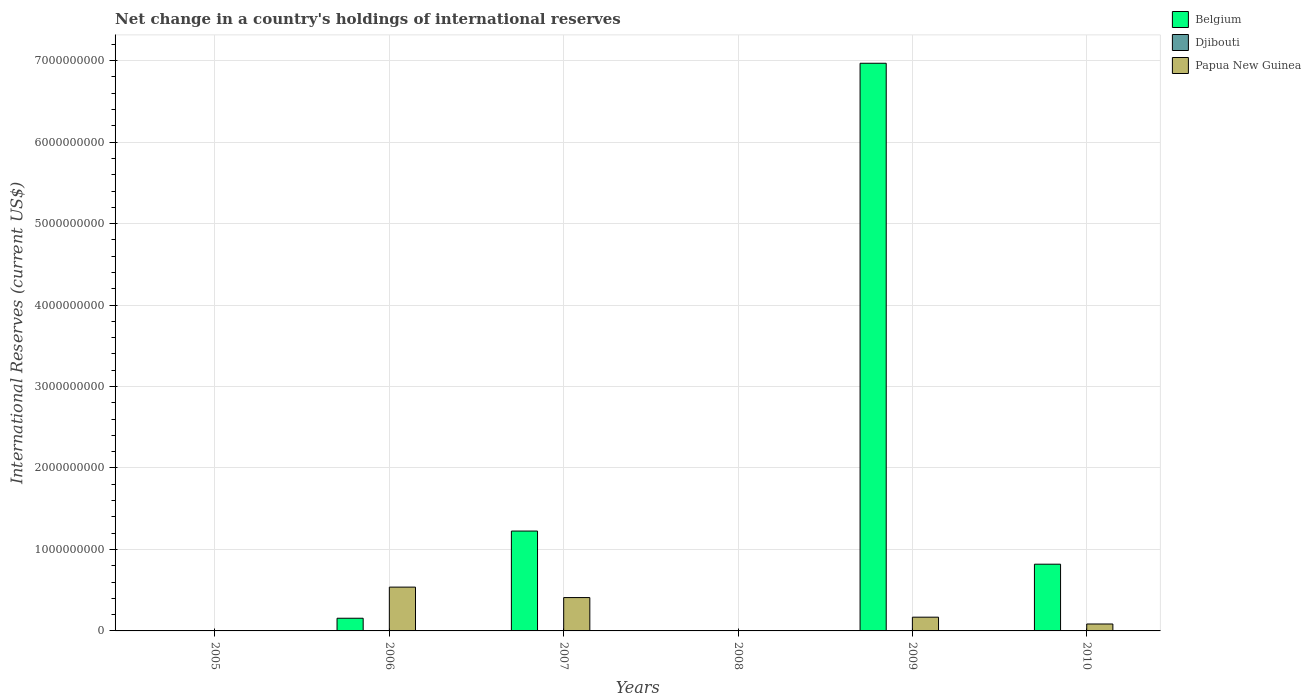Are the number of bars on each tick of the X-axis equal?
Offer a very short reply. No. How many bars are there on the 6th tick from the right?
Offer a very short reply. 0. What is the label of the 3rd group of bars from the left?
Make the answer very short. 2007. What is the international reserves in Papua New Guinea in 2010?
Keep it short and to the point. 8.50e+07. Across all years, what is the maximum international reserves in Papua New Guinea?
Ensure brevity in your answer.  5.38e+08. Across all years, what is the minimum international reserves in Papua New Guinea?
Provide a short and direct response. 0. In which year was the international reserves in Belgium maximum?
Provide a succinct answer. 2009. What is the total international reserves in Papua New Guinea in the graph?
Keep it short and to the point. 1.20e+09. What is the difference between the international reserves in Papua New Guinea in 2007 and that in 2010?
Offer a very short reply. 3.24e+08. What is the difference between the international reserves in Djibouti in 2007 and the international reserves in Papua New Guinea in 2006?
Offer a very short reply. -5.38e+08. What is the average international reserves in Belgium per year?
Give a very brief answer. 1.53e+09. In the year 2006, what is the difference between the international reserves in Papua New Guinea and international reserves in Belgium?
Provide a succinct answer. 3.82e+08. What is the ratio of the international reserves in Belgium in 2006 to that in 2010?
Your answer should be very brief. 0.19. Is the international reserves in Belgium in 2007 less than that in 2010?
Offer a very short reply. No. Is the difference between the international reserves in Papua New Guinea in 2006 and 2010 greater than the difference between the international reserves in Belgium in 2006 and 2010?
Provide a short and direct response. Yes. What is the difference between the highest and the second highest international reserves in Belgium?
Your answer should be very brief. 5.74e+09. What is the difference between the highest and the lowest international reserves in Djibouti?
Your response must be concise. 4.65e+06. How many bars are there?
Ensure brevity in your answer.  9. What is the difference between two consecutive major ticks on the Y-axis?
Keep it short and to the point. 1.00e+09. Does the graph contain grids?
Ensure brevity in your answer.  Yes. Where does the legend appear in the graph?
Provide a succinct answer. Top right. How many legend labels are there?
Your answer should be very brief. 3. How are the legend labels stacked?
Ensure brevity in your answer.  Vertical. What is the title of the graph?
Provide a succinct answer. Net change in a country's holdings of international reserves. What is the label or title of the Y-axis?
Keep it short and to the point. International Reserves (current US$). What is the International Reserves (current US$) in Djibouti in 2005?
Offer a very short reply. 0. What is the International Reserves (current US$) in Papua New Guinea in 2005?
Give a very brief answer. 0. What is the International Reserves (current US$) in Belgium in 2006?
Provide a short and direct response. 1.56e+08. What is the International Reserves (current US$) of Djibouti in 2006?
Give a very brief answer. 4.65e+06. What is the International Reserves (current US$) of Papua New Guinea in 2006?
Ensure brevity in your answer.  5.38e+08. What is the International Reserves (current US$) of Belgium in 2007?
Your response must be concise. 1.23e+09. What is the International Reserves (current US$) of Papua New Guinea in 2007?
Offer a very short reply. 4.09e+08. What is the International Reserves (current US$) of Djibouti in 2008?
Your answer should be very brief. 0. What is the International Reserves (current US$) in Belgium in 2009?
Give a very brief answer. 6.97e+09. What is the International Reserves (current US$) in Djibouti in 2009?
Ensure brevity in your answer.  0. What is the International Reserves (current US$) in Papua New Guinea in 2009?
Provide a short and direct response. 1.69e+08. What is the International Reserves (current US$) in Belgium in 2010?
Ensure brevity in your answer.  8.19e+08. What is the International Reserves (current US$) in Djibouti in 2010?
Keep it short and to the point. 0. What is the International Reserves (current US$) of Papua New Guinea in 2010?
Ensure brevity in your answer.  8.50e+07. Across all years, what is the maximum International Reserves (current US$) in Belgium?
Your response must be concise. 6.97e+09. Across all years, what is the maximum International Reserves (current US$) of Djibouti?
Give a very brief answer. 4.65e+06. Across all years, what is the maximum International Reserves (current US$) of Papua New Guinea?
Ensure brevity in your answer.  5.38e+08. Across all years, what is the minimum International Reserves (current US$) of Djibouti?
Ensure brevity in your answer.  0. What is the total International Reserves (current US$) of Belgium in the graph?
Your answer should be very brief. 9.17e+09. What is the total International Reserves (current US$) of Djibouti in the graph?
Keep it short and to the point. 4.65e+06. What is the total International Reserves (current US$) of Papua New Guinea in the graph?
Provide a succinct answer. 1.20e+09. What is the difference between the International Reserves (current US$) in Belgium in 2006 and that in 2007?
Your answer should be compact. -1.07e+09. What is the difference between the International Reserves (current US$) in Papua New Guinea in 2006 and that in 2007?
Provide a succinct answer. 1.28e+08. What is the difference between the International Reserves (current US$) in Belgium in 2006 and that in 2009?
Your response must be concise. -6.81e+09. What is the difference between the International Reserves (current US$) of Papua New Guinea in 2006 and that in 2009?
Keep it short and to the point. 3.69e+08. What is the difference between the International Reserves (current US$) in Belgium in 2006 and that in 2010?
Keep it short and to the point. -6.63e+08. What is the difference between the International Reserves (current US$) of Papua New Guinea in 2006 and that in 2010?
Your answer should be compact. 4.53e+08. What is the difference between the International Reserves (current US$) of Belgium in 2007 and that in 2009?
Ensure brevity in your answer.  -5.74e+09. What is the difference between the International Reserves (current US$) in Papua New Guinea in 2007 and that in 2009?
Keep it short and to the point. 2.41e+08. What is the difference between the International Reserves (current US$) in Belgium in 2007 and that in 2010?
Offer a terse response. 4.07e+08. What is the difference between the International Reserves (current US$) of Papua New Guinea in 2007 and that in 2010?
Make the answer very short. 3.24e+08. What is the difference between the International Reserves (current US$) of Belgium in 2009 and that in 2010?
Keep it short and to the point. 6.15e+09. What is the difference between the International Reserves (current US$) in Papua New Guinea in 2009 and that in 2010?
Your response must be concise. 8.36e+07. What is the difference between the International Reserves (current US$) of Belgium in 2006 and the International Reserves (current US$) of Papua New Guinea in 2007?
Provide a short and direct response. -2.54e+08. What is the difference between the International Reserves (current US$) of Djibouti in 2006 and the International Reserves (current US$) of Papua New Guinea in 2007?
Offer a terse response. -4.05e+08. What is the difference between the International Reserves (current US$) of Belgium in 2006 and the International Reserves (current US$) of Papua New Guinea in 2009?
Make the answer very short. -1.29e+07. What is the difference between the International Reserves (current US$) of Djibouti in 2006 and the International Reserves (current US$) of Papua New Guinea in 2009?
Offer a very short reply. -1.64e+08. What is the difference between the International Reserves (current US$) of Belgium in 2006 and the International Reserves (current US$) of Papua New Guinea in 2010?
Provide a short and direct response. 7.07e+07. What is the difference between the International Reserves (current US$) of Djibouti in 2006 and the International Reserves (current US$) of Papua New Guinea in 2010?
Your answer should be compact. -8.03e+07. What is the difference between the International Reserves (current US$) of Belgium in 2007 and the International Reserves (current US$) of Papua New Guinea in 2009?
Your answer should be compact. 1.06e+09. What is the difference between the International Reserves (current US$) in Belgium in 2007 and the International Reserves (current US$) in Papua New Guinea in 2010?
Give a very brief answer. 1.14e+09. What is the difference between the International Reserves (current US$) in Belgium in 2009 and the International Reserves (current US$) in Papua New Guinea in 2010?
Offer a very short reply. 6.88e+09. What is the average International Reserves (current US$) in Belgium per year?
Ensure brevity in your answer.  1.53e+09. What is the average International Reserves (current US$) in Djibouti per year?
Provide a succinct answer. 7.75e+05. What is the average International Reserves (current US$) of Papua New Guinea per year?
Offer a very short reply. 2.00e+08. In the year 2006, what is the difference between the International Reserves (current US$) in Belgium and International Reserves (current US$) in Djibouti?
Provide a short and direct response. 1.51e+08. In the year 2006, what is the difference between the International Reserves (current US$) in Belgium and International Reserves (current US$) in Papua New Guinea?
Your answer should be very brief. -3.82e+08. In the year 2006, what is the difference between the International Reserves (current US$) in Djibouti and International Reserves (current US$) in Papua New Guinea?
Offer a very short reply. -5.33e+08. In the year 2007, what is the difference between the International Reserves (current US$) of Belgium and International Reserves (current US$) of Papua New Guinea?
Ensure brevity in your answer.  8.16e+08. In the year 2009, what is the difference between the International Reserves (current US$) in Belgium and International Reserves (current US$) in Papua New Guinea?
Provide a succinct answer. 6.80e+09. In the year 2010, what is the difference between the International Reserves (current US$) in Belgium and International Reserves (current US$) in Papua New Guinea?
Ensure brevity in your answer.  7.34e+08. What is the ratio of the International Reserves (current US$) in Belgium in 2006 to that in 2007?
Your answer should be very brief. 0.13. What is the ratio of the International Reserves (current US$) in Papua New Guinea in 2006 to that in 2007?
Provide a short and direct response. 1.31. What is the ratio of the International Reserves (current US$) in Belgium in 2006 to that in 2009?
Your answer should be compact. 0.02. What is the ratio of the International Reserves (current US$) in Papua New Guinea in 2006 to that in 2009?
Your response must be concise. 3.19. What is the ratio of the International Reserves (current US$) of Belgium in 2006 to that in 2010?
Your answer should be compact. 0.19. What is the ratio of the International Reserves (current US$) of Papua New Guinea in 2006 to that in 2010?
Keep it short and to the point. 6.33. What is the ratio of the International Reserves (current US$) of Belgium in 2007 to that in 2009?
Your answer should be compact. 0.18. What is the ratio of the International Reserves (current US$) in Papua New Guinea in 2007 to that in 2009?
Provide a succinct answer. 2.43. What is the ratio of the International Reserves (current US$) in Belgium in 2007 to that in 2010?
Make the answer very short. 1.5. What is the ratio of the International Reserves (current US$) in Papua New Guinea in 2007 to that in 2010?
Provide a short and direct response. 4.82. What is the ratio of the International Reserves (current US$) in Belgium in 2009 to that in 2010?
Provide a short and direct response. 8.51. What is the ratio of the International Reserves (current US$) in Papua New Guinea in 2009 to that in 2010?
Provide a short and direct response. 1.98. What is the difference between the highest and the second highest International Reserves (current US$) of Belgium?
Ensure brevity in your answer.  5.74e+09. What is the difference between the highest and the second highest International Reserves (current US$) in Papua New Guinea?
Your answer should be very brief. 1.28e+08. What is the difference between the highest and the lowest International Reserves (current US$) of Belgium?
Provide a succinct answer. 6.97e+09. What is the difference between the highest and the lowest International Reserves (current US$) of Djibouti?
Make the answer very short. 4.65e+06. What is the difference between the highest and the lowest International Reserves (current US$) in Papua New Guinea?
Provide a short and direct response. 5.38e+08. 